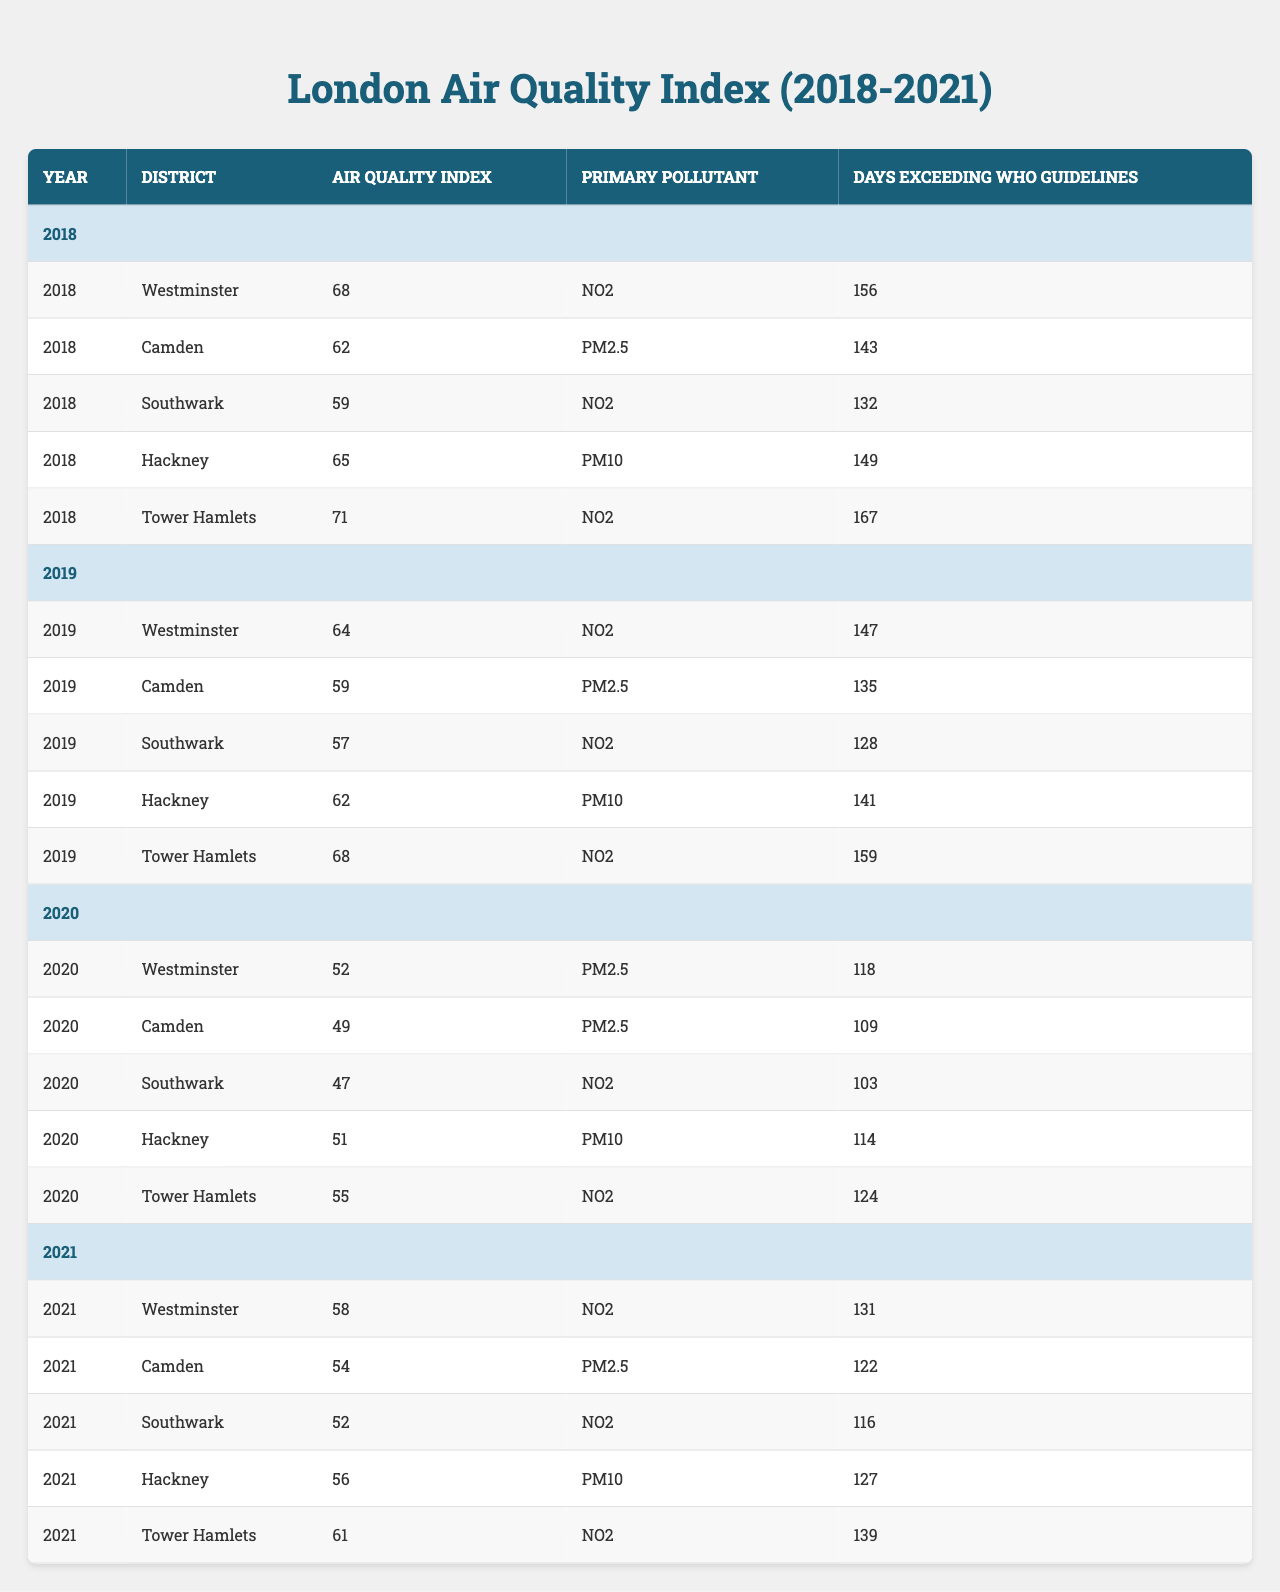What was the highest Air Quality Index recorded in Westminster? The table shows that the Air Quality Index for Westminster reached its highest at 68 in the year 2018.
Answer: 68 In which year did Camden have the lowest Air Quality Index? According to the table, Camden's lowest Air Quality Index was 49, recorded in 2020.
Answer: 2020 How many days did Tower Hamlets exceed WHO guidelines in 2019? The table indicates that Tower Hamlets exceeded WHO guidelines for 159 days in 2019.
Answer: 159 What is the average Air Quality Index for Southwark from 2018 to 2021? The Air Quality Index for Southwark is 59 (2018) + 57 (2019) + 47 (2020) + 52 (2021) = 215. Dividing by 4, the average is 215 / 4 = 53.75.
Answer: 53.75 Is PM2.5 the primary pollutant for Southwark in 2020? The table confirms that the primary pollutant for Southwark in 2020 was NO2, not PM2.5.
Answer: No Which district had the highest number of days exceeding WHO guidelines in 2021? Examining the table for 2021, Tower Hamlets had the highest count with 139 days exceeding WHO guidelines.
Answer: Tower Hamlets What was the decline in Air Quality Index for Hackney from 2018 to 2020? The Air Quality Index for Hackney in 2018 was 65, and it decreased to 51 in 2020. The decline is 65 - 51 = 14.
Answer: 14 In terms of primary pollutants, were there more instances of NO2 or PM2.5 across all districts in 2019? Reviewing the table for 2019, NO2 was listed as the primary pollutant for 4 districts (Westminster, Southwark, Tower Hamlets) and PM2.5 for 2 districts (Camden).
Answer: More instances of NO2 What is the difference in days exceeding WHO guidelines between Westminster in 2018 and 2021? Westminster had 156 days in 2018 and 131 days in 2021. The difference is 156 - 131 = 25 days.
Answer: 25 days Did the Air Quality Index improve in Camden from 2019 to 2020? Between 2019 (AQI of 59) and 2020 (AQI of 49), the Air Quality Index indeed improved, as it decreased.
Answer: Yes 